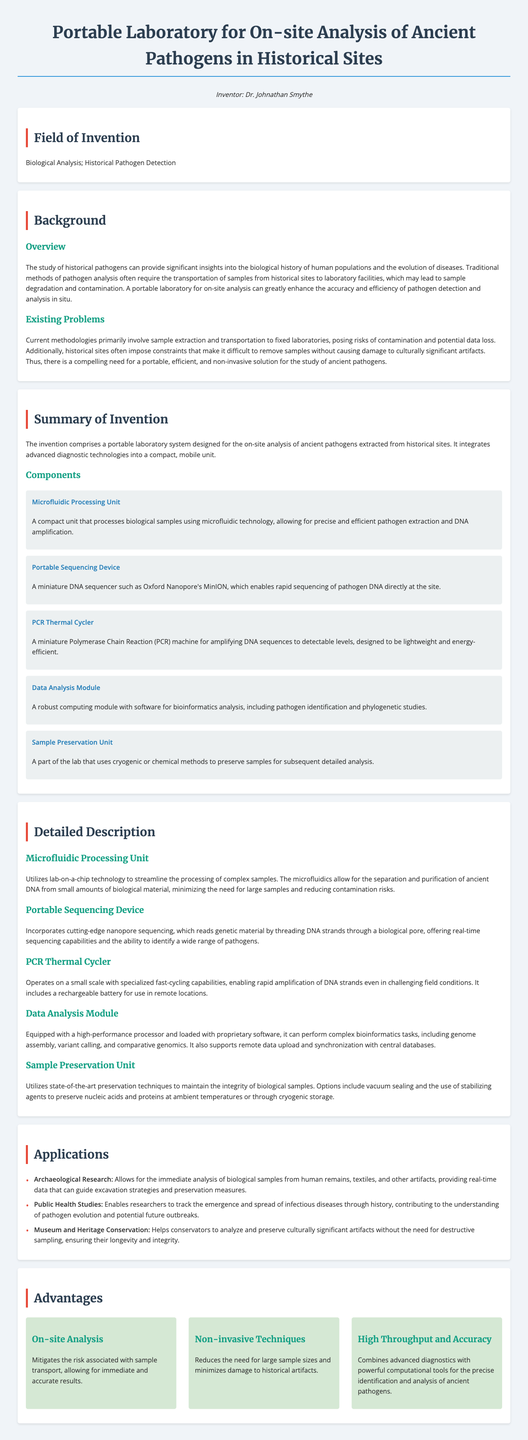What is the name of the inventor? The document mentions Dr. Johnathan Smythe as the inventor of the portable laboratory.
Answer: Dr. Johnathan Smythe What are the key components of the invention? The key components include a Microfluidic Processing Unit, Portable Sequencing Device, PCR Thermal Cycler, Data Analysis Module, and Sample Preservation Unit.
Answer: Microfluidic Processing Unit, Portable Sequencing Device, PCR Thermal Cycler, Data Analysis Module, Sample Preservation Unit What is the primary field of invention? The document states that the field of invention relates to Biological Analysis and Historical Pathogen Detection.
Answer: Biological Analysis; Historical Pathogen Detection What is one application of the portable laboratory? One application mentioned is for Archaeological Research, providing immediate analysis of biological samples.
Answer: Archaeological Research What is a primary benefit of on-site analysis? On-site analysis mitigates the risk associated with sample transport, allowing for immediate and accurate results.
Answer: Immediate and accurate results What technology does the portable sequencing device utilize? The portable sequencing device incorporates cutting-edge nanopore sequencing technology.
Answer: Nanopore sequencing What is a problem with current methodologies for pathogen analysis? The current methodologies pose risks of contamination and potential data loss due to sample transportation.
Answer: Contamination and potential data loss How does the Sample Preservation Unit maintain biological sample integrity? The Sample Preservation Unit uses vacuum sealing and stabilizing agents to preserve samples.
Answer: Vacuum sealing and stabilizing agents 